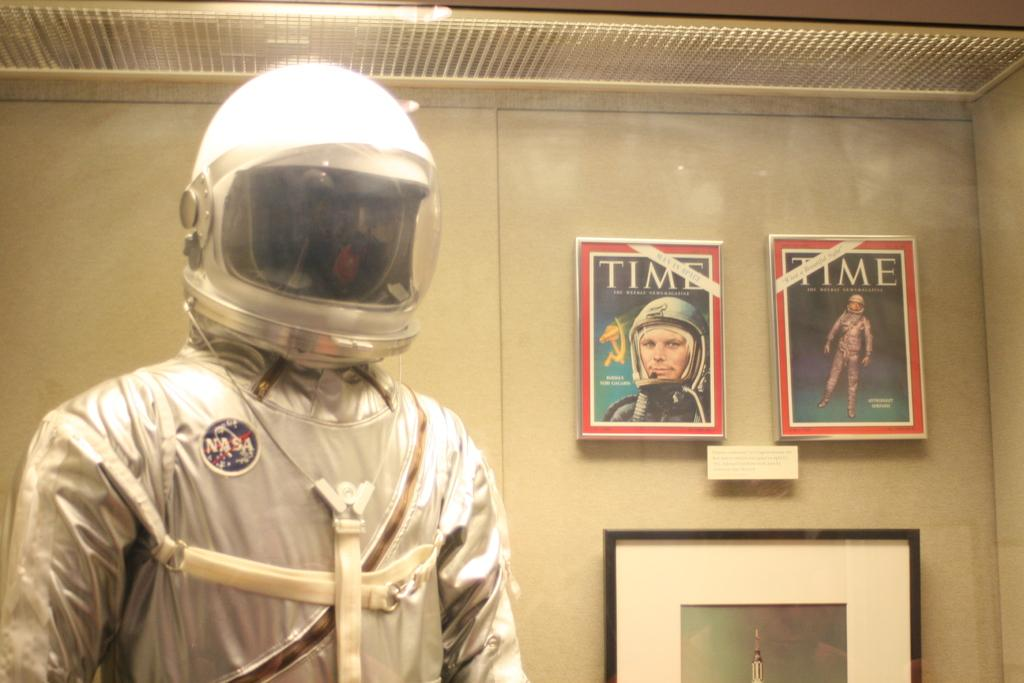Who is present in the image? There is a person in the image. What is the person wearing? The person is wearing a suit and a helmet. What can be seen on the wall in the image? There are posters on the wall and a photo attached to the wall. What type of calendar is hanging on the wall in the image? There is no calendar present in the image; only posters and a photo are visible on the wall. 